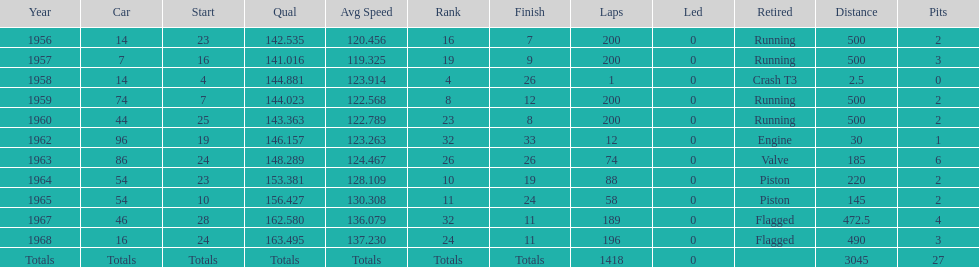How many times did he finish all 200 laps? 4. 